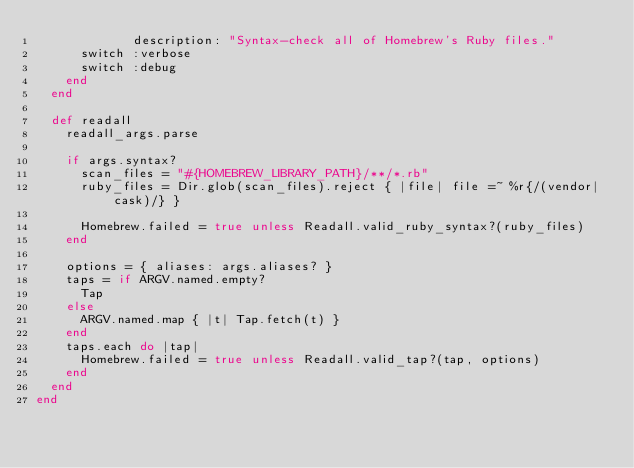Convert code to text. <code><loc_0><loc_0><loc_500><loc_500><_Ruby_>             description: "Syntax-check all of Homebrew's Ruby files."
      switch :verbose
      switch :debug
    end
  end

  def readall
    readall_args.parse

    if args.syntax?
      scan_files = "#{HOMEBREW_LIBRARY_PATH}/**/*.rb"
      ruby_files = Dir.glob(scan_files).reject { |file| file =~ %r{/(vendor|cask)/} }

      Homebrew.failed = true unless Readall.valid_ruby_syntax?(ruby_files)
    end

    options = { aliases: args.aliases? }
    taps = if ARGV.named.empty?
      Tap
    else
      ARGV.named.map { |t| Tap.fetch(t) }
    end
    taps.each do |tap|
      Homebrew.failed = true unless Readall.valid_tap?(tap, options)
    end
  end
end
</code> 